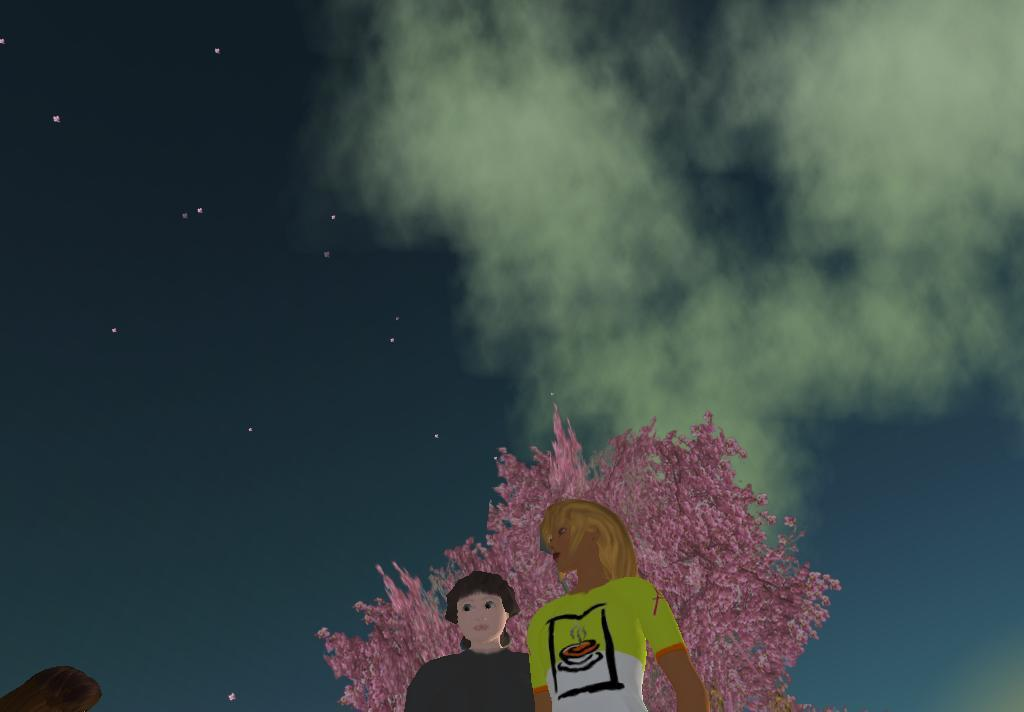What type of pictures can be seen in the image? There are animation pictures in the image. What is the color of the tree in the image? The tree in the image is pink in color. What can be seen in the background of the image? The sky is visible in the image. What celestial objects are present in the image? Stars are present in the image. How does the knot in the tree affect the animation pictures in the image? There is no knot present in the tree or the image; the tree is described as being pink in color. 